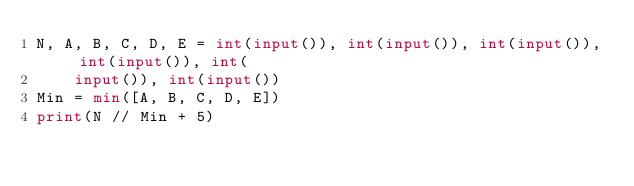<code> <loc_0><loc_0><loc_500><loc_500><_Python_>N, A, B, C, D, E = int(input()), int(input()), int(input()), int(input()), int(
    input()), int(input())
Min = min([A, B, C, D, E])
print(N // Min + 5)
</code> 